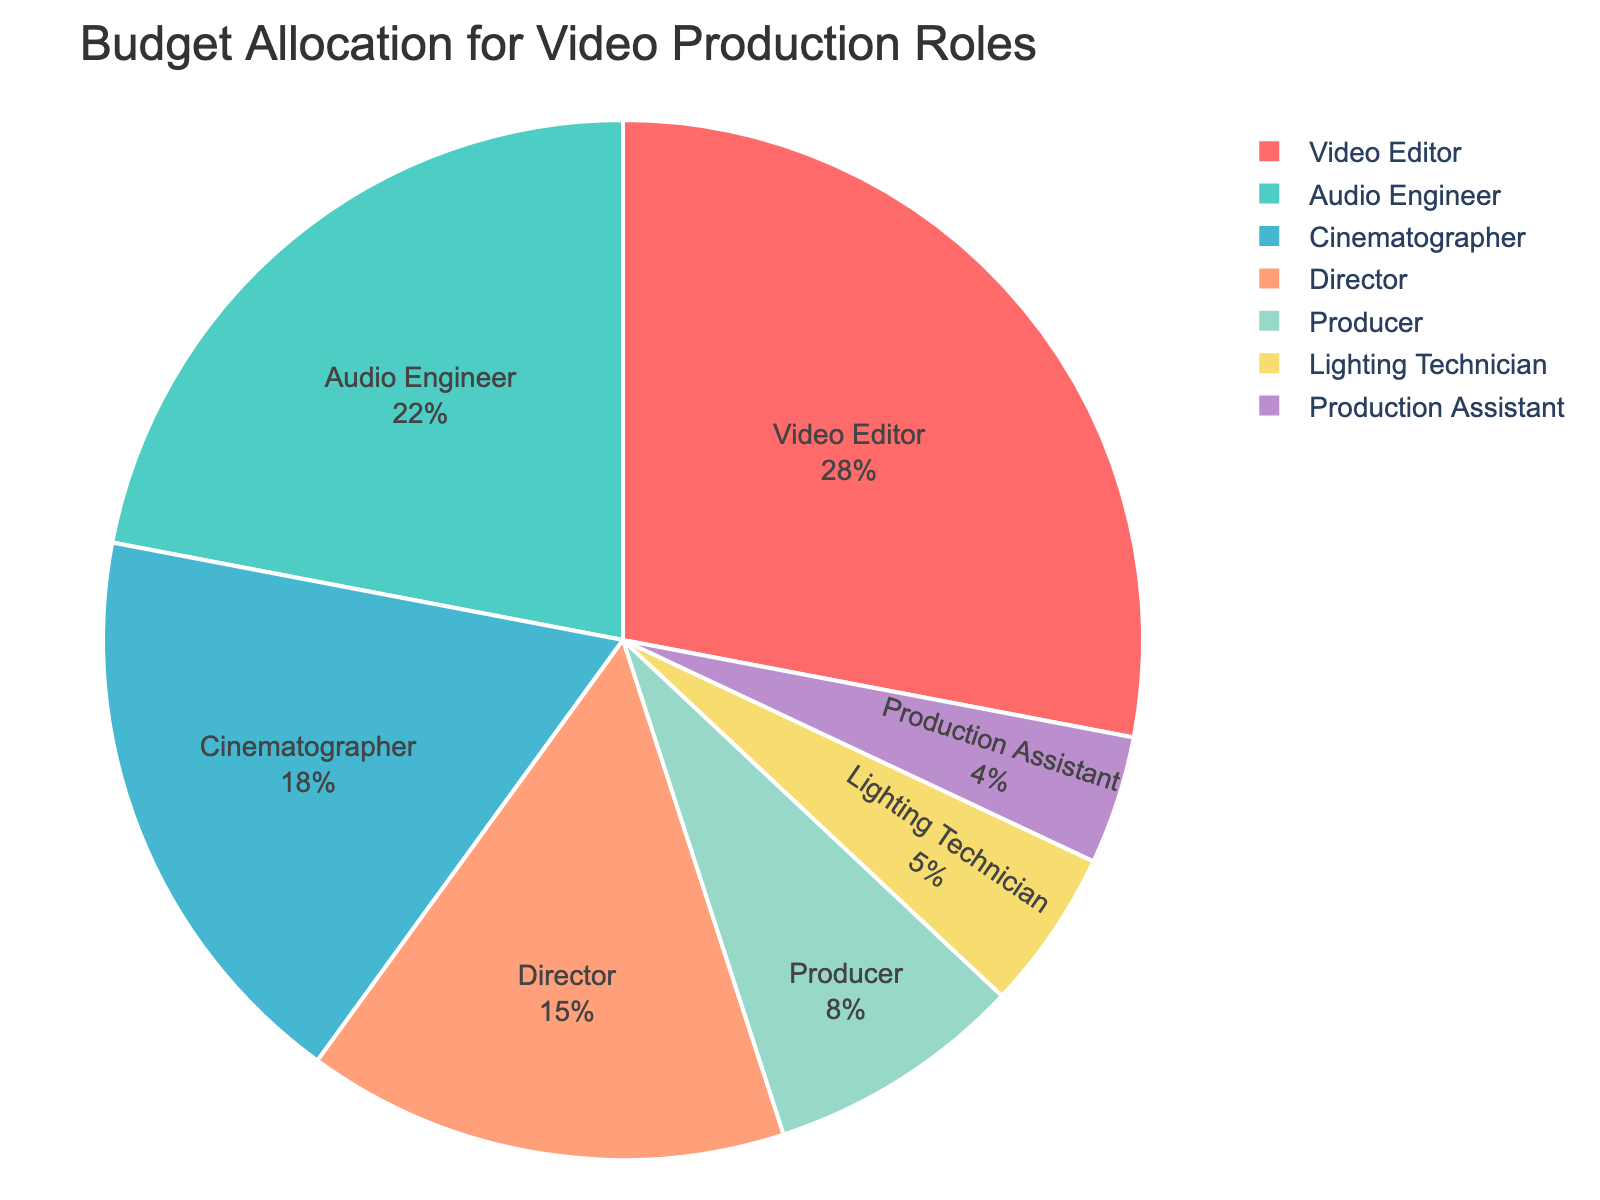What role receives the highest percentage of the budget? The pie chart shows that the slice representing 'Video Editor' is the largest. This indicates that the Video Editor receives the highest percentage of the budget.
Answer: Video Editor How much more budget percentage does the Video Editor receive compared to the Producer? The Video Editor's budget percentage is 28%, and the Producer's budget percentage is 8%. The difference is 28% - 8% = 20%.
Answer: 20% What is the combined budget percentage for the Video Editor and the Audio Engineer? The Video Editor has a budget of 28%, and the Audio Engineer has a budget of 22%. Adding these together, 28% + 22% = 50%.
Answer: 50% Is the budget percentage for the Director greater than that for the Producer? The pie chart shows that the Director has a budget of 15%, while the Producer has a budget of 8%. Therefore, the Director's budget percentage is greater than the Producer's.
Answer: Yes Which role has the smallest percentage allocation in the budget? From the pie chart, the smallest slice represents the 'Production Assistant,' with a budget percentage of 4%.
Answer: Production Assistant What's the difference in budget percentage between the Cinematographer and the Lighting Technician? The Cinematographer has a budget of 18%, and the Lighting Technician has a budget of 5%. The difference is 18% - 5% = 13%.
Answer: 13% Which roles combined have a budget percentage equal to or more than 30%? The roles should be checked cumulatively: 
1. Audio Engineer (22%) 
2. Lighting Technician (5%) 
3. Production Assistant (4%)
Together, Audio Engineer (22%) + Lighting Technician (5%) + Production Assistant (4%) = 31%.
Answer: Audio Engineer, Lighting Technician, Production Assistant Comparing the Director and the Cinematographer, who has a larger budget allocation, and by how much? The Director has 15%, and the Cinematographer has 18%. The difference is 18% - 15% = 3%. The Cinematographer has a larger allocation by 3%.
Answer: Cinematographer, by 3% Based on the visual attributes in the pie chart, which role is represented by the green slice? Observing the colors in the pie chart, the green slice corresponds to 'Audio Engineer'.
Answer: Audio Engineer 